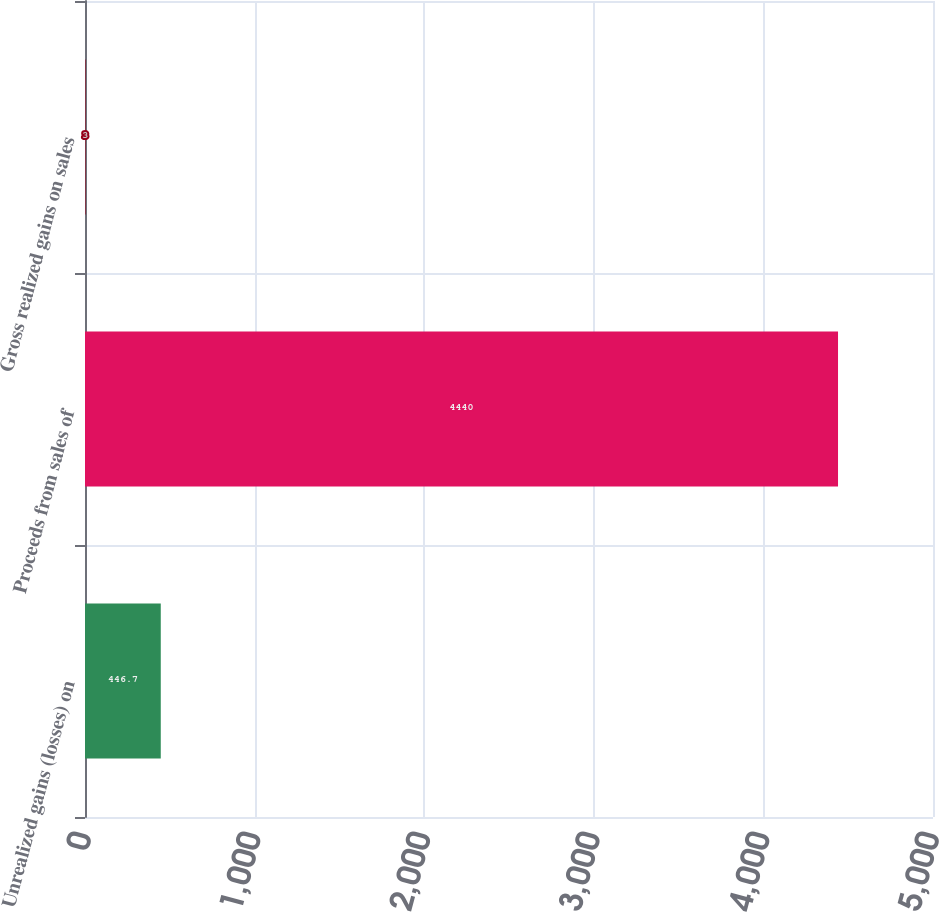Convert chart. <chart><loc_0><loc_0><loc_500><loc_500><bar_chart><fcel>Unrealized gains (losses) on<fcel>Proceeds from sales of<fcel>Gross realized gains on sales<nl><fcel>446.7<fcel>4440<fcel>3<nl></chart> 